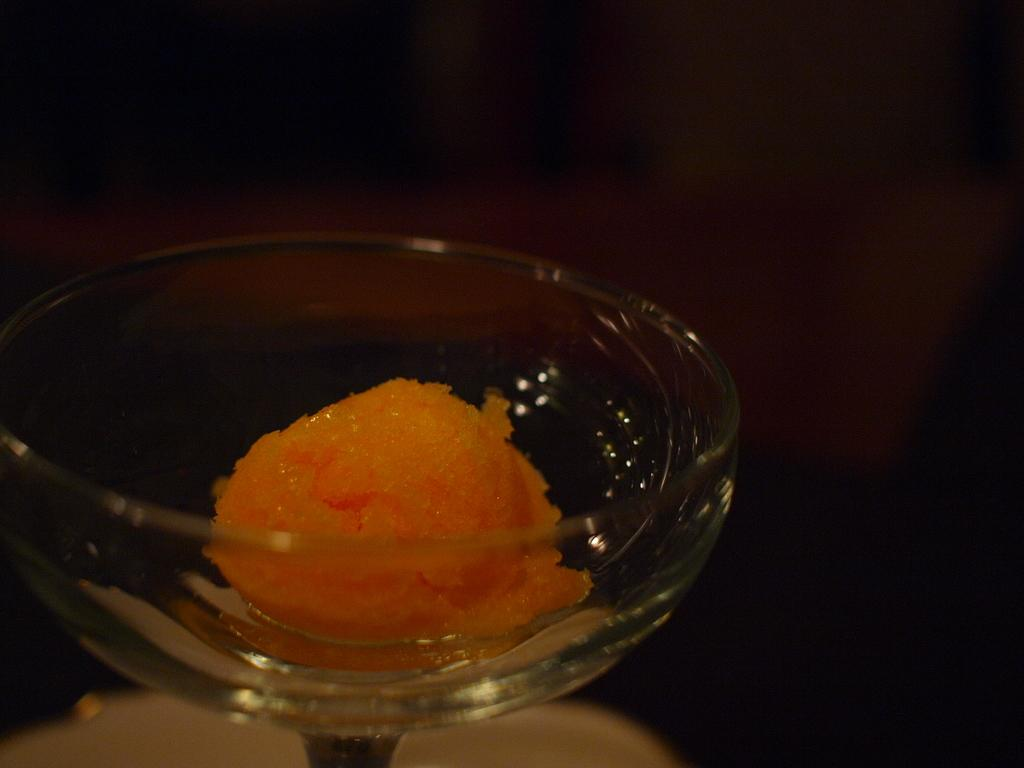What is contained in the glass in the image? There is food in a glass in the image. How many ladybugs can be seen crawling on the food in the glass? There are no ladybugs present in the image; it only shows food in a glass. 